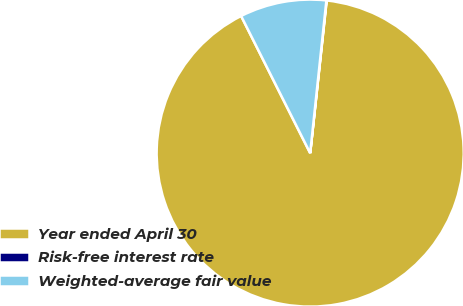Convert chart to OTSL. <chart><loc_0><loc_0><loc_500><loc_500><pie_chart><fcel>Year ended April 30<fcel>Risk-free interest rate<fcel>Weighted-average fair value<nl><fcel>90.86%<fcel>0.03%<fcel>9.11%<nl></chart> 